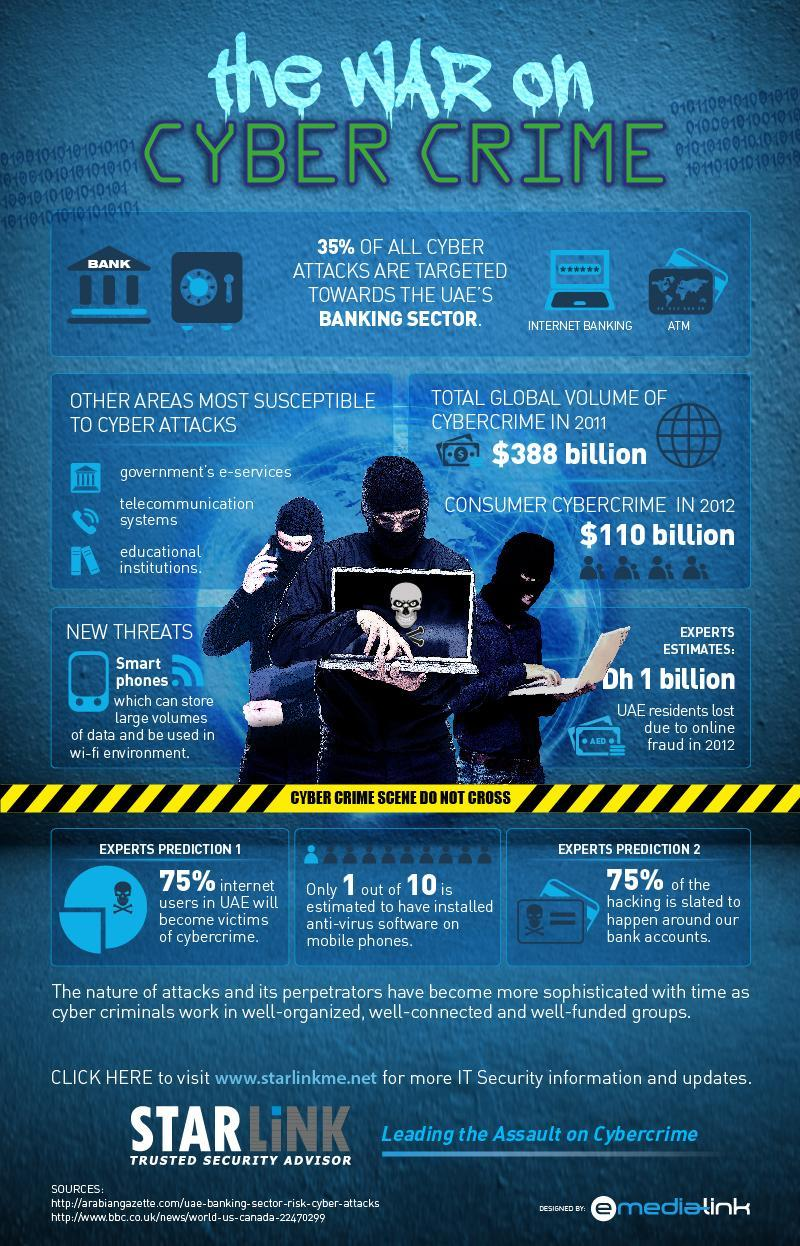What percent of internet users in UAE will not become victims of cybercrime as per the experts prediction?
Answer the question with a short phrase. 25% What is the volume of consumer cybercrime reported in 2012? $110 billion What is the estimated loss incurred by UAE residents due to online fraud according to the experts in 2012? Dh 1 billion 